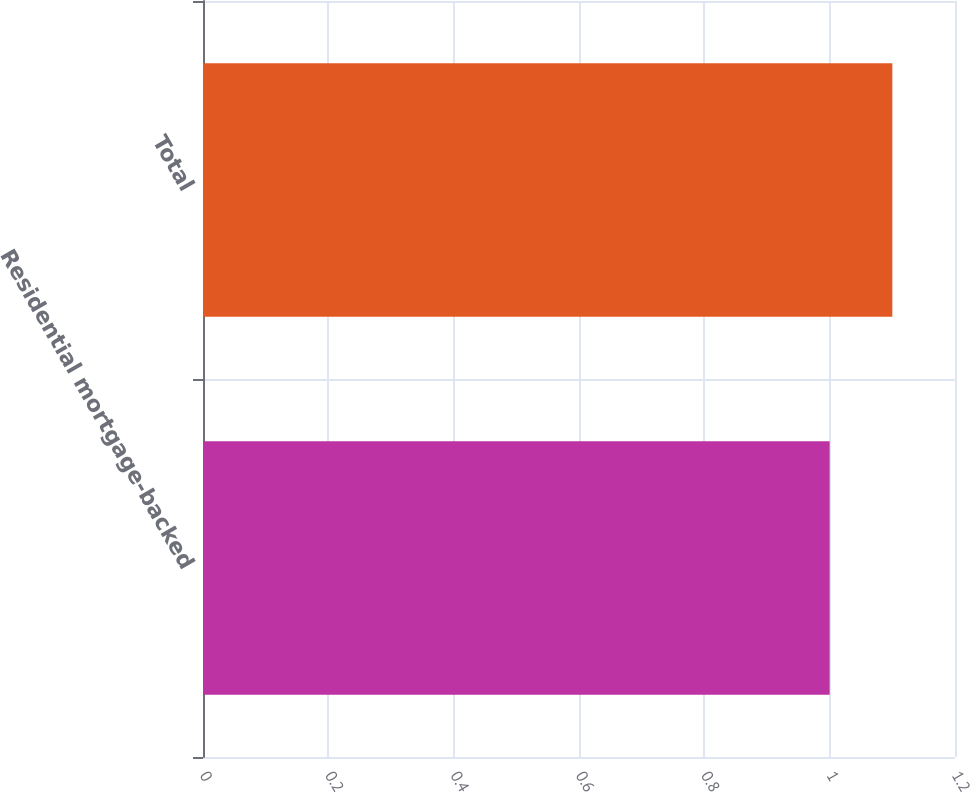Convert chart to OTSL. <chart><loc_0><loc_0><loc_500><loc_500><bar_chart><fcel>Residential mortgage-backed<fcel>Total<nl><fcel>1<fcel>1.1<nl></chart> 